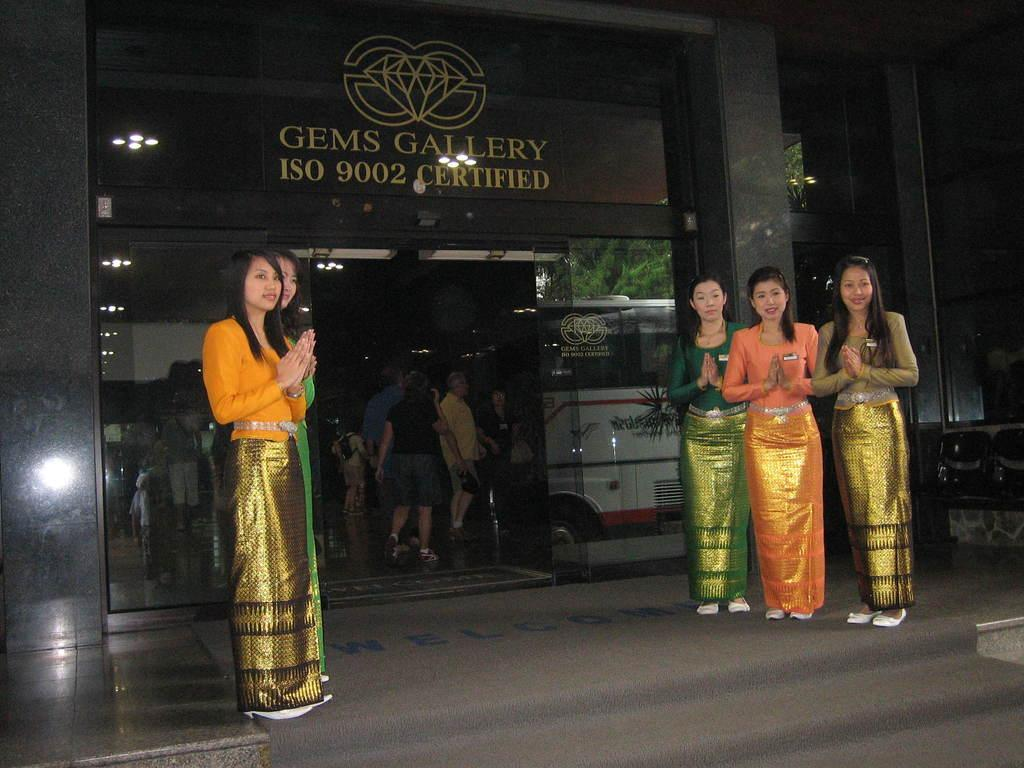What is the primary subject of the image? There are women standing in the image. What activity are some people engaged in? There are people walking into a building in the image. What additional detail can be observed in the image? There is a reflection of a bus on a mirror in the image. What type of rake is being used by the mom in the image? There is no mom or rake present in the image. 